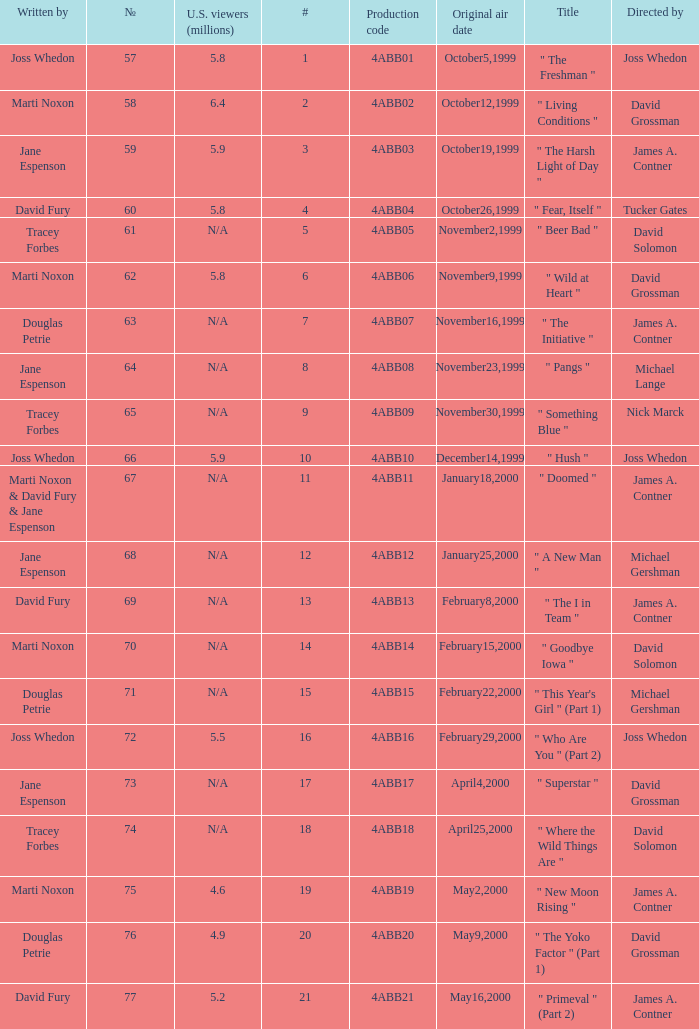What is the series No when the season 4 # is 18? 74.0. 